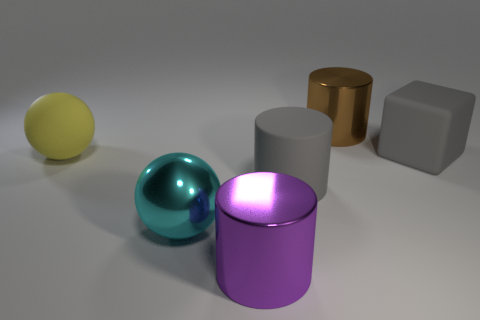What number of other things are the same size as the matte sphere?
Make the answer very short. 5. How many cyan objects are either metallic spheres or big spheres?
Your answer should be compact. 1. How many rubber things are both to the right of the large yellow matte thing and to the left of the purple metal cylinder?
Your answer should be compact. 0. What is the sphere in front of the cube behind the large sphere that is in front of the yellow ball made of?
Make the answer very short. Metal. What number of gray things have the same material as the brown object?
Ensure brevity in your answer.  0. The big object that is the same color as the big rubber cylinder is what shape?
Your answer should be compact. Cube. There is a cyan thing that is the same size as the rubber ball; what is its shape?
Give a very brief answer. Sphere. There is a large cylinder that is the same color as the matte cube; what is it made of?
Give a very brief answer. Rubber. There is a large purple thing; are there any big brown shiny objects to the right of it?
Make the answer very short. Yes. Is there a big purple metallic object of the same shape as the cyan shiny thing?
Offer a very short reply. No. 